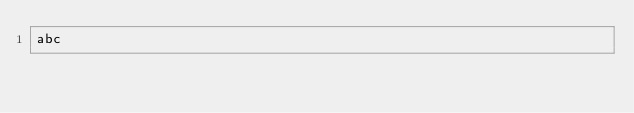<code> <loc_0><loc_0><loc_500><loc_500><_Rust_>abc</code> 